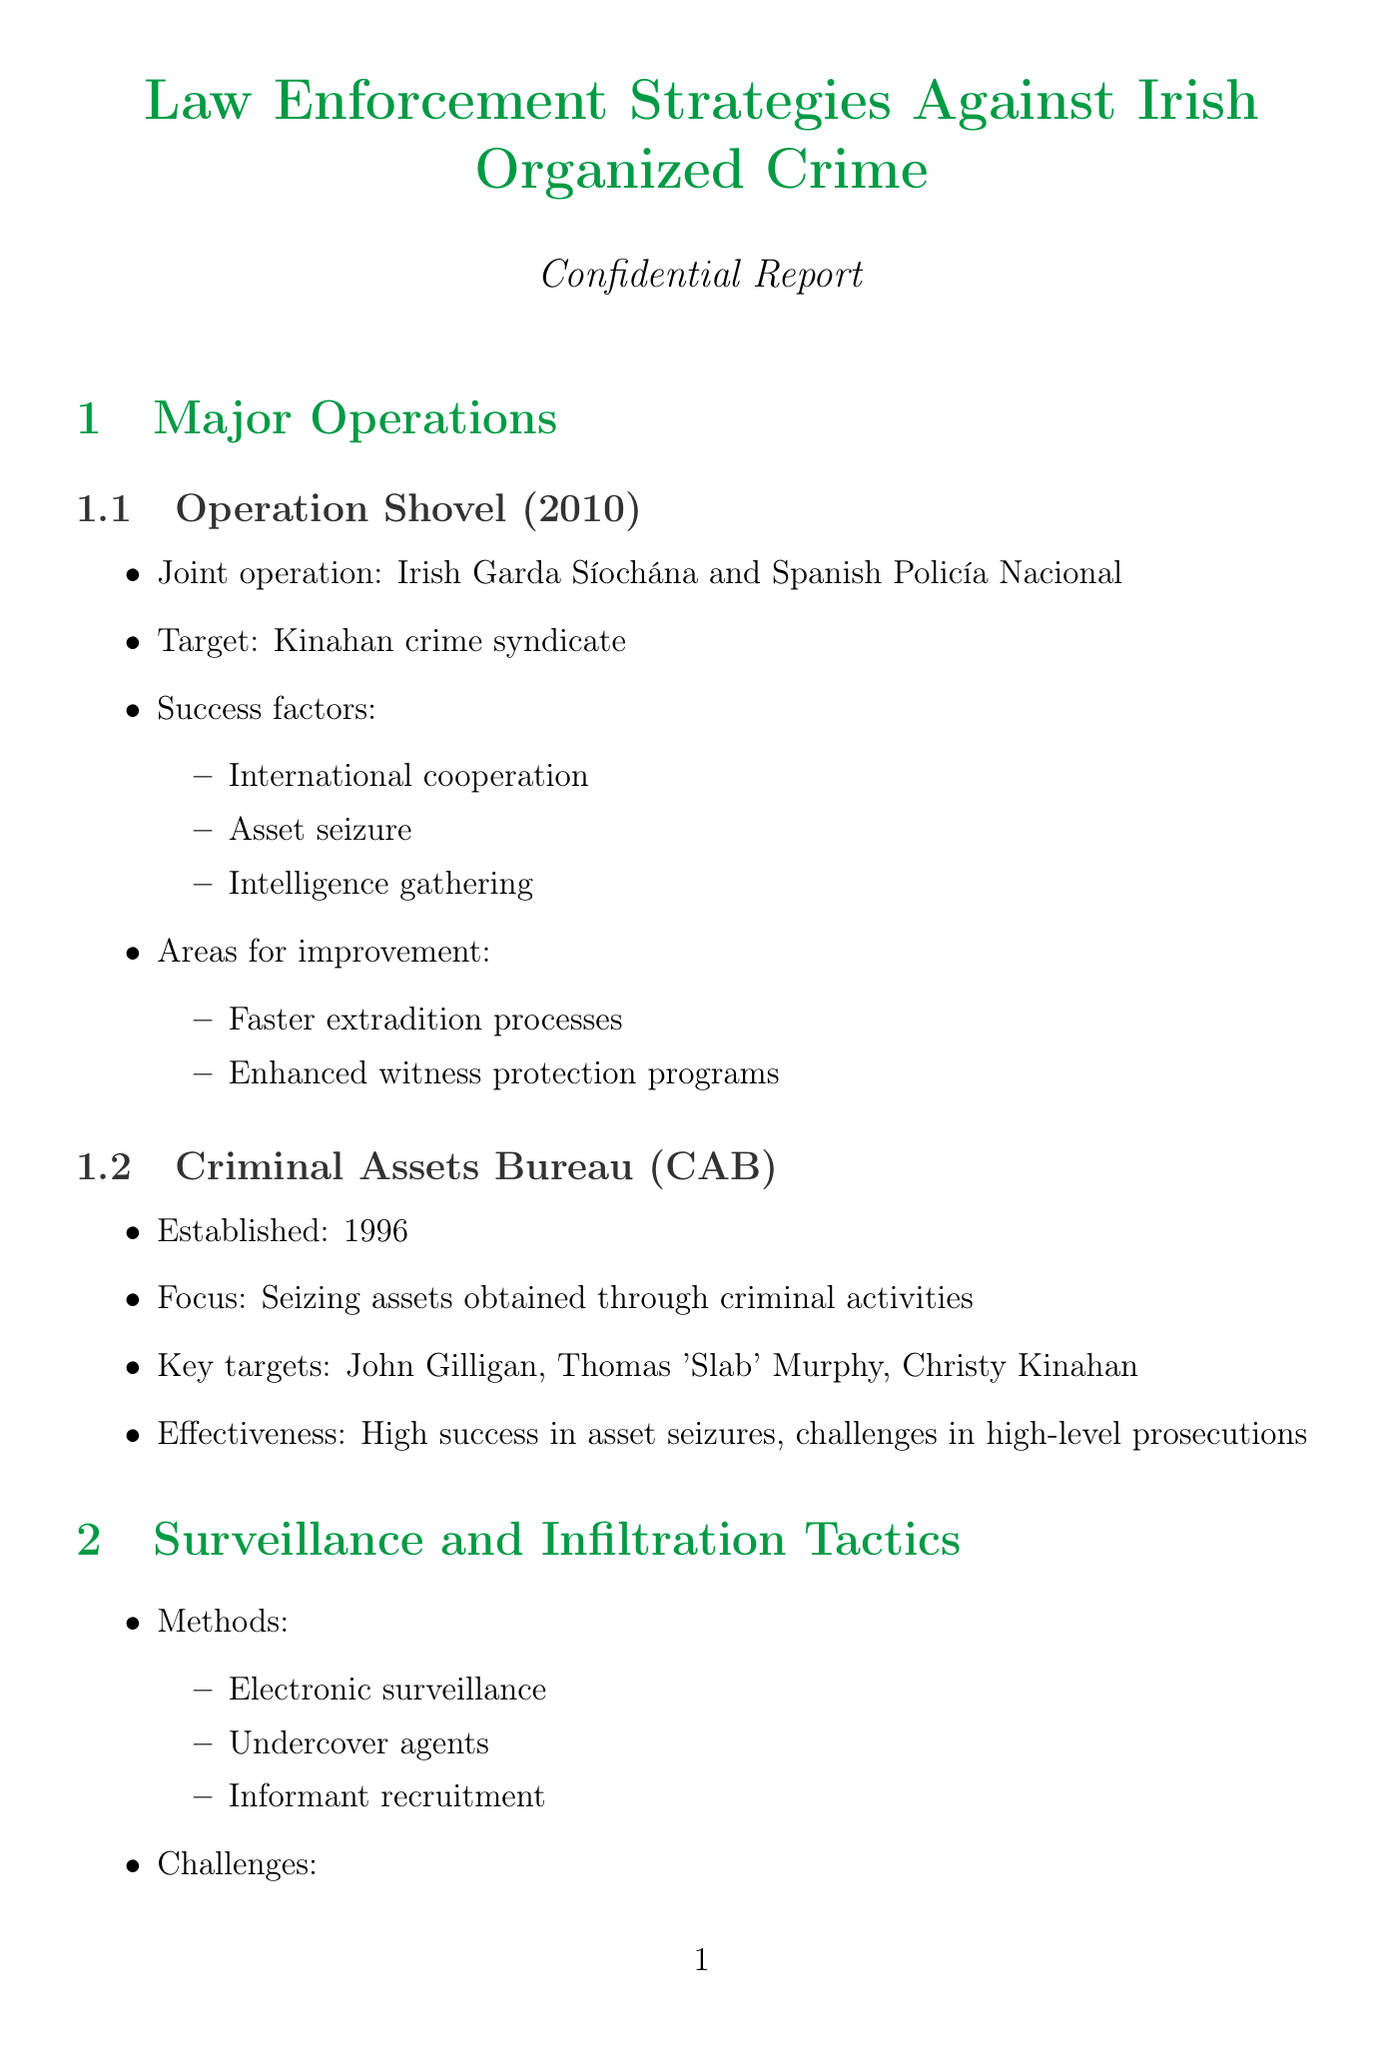what is the name of the joint operation targeting the Kinahan crime syndicate? The operation mentioned in the document is a joint effort between Irish Garda Síochána and Spanish Policía Nacional aimed at the Kinahan crime syndicate.
Answer: Operation Shovel when was the Criminal Assets Bureau established? The document states that the Criminal Assets Bureau, which focuses on seizing assets obtained through criminal activities, was established in 1996.
Answer: 1996 who is the leader of the Hutch Gang? The document identifies Gerry 'The Monk' Hutch as the leader of the Hutch Gang.
Answer: Gerry 'The Monk' Hutch what is one of the primary activities of the Kinahan Organized Crime Group? The document lists drug trafficking, money laundering, and arms dealing as primary activities of the Kinahan Organized Crime Group.
Answer: Drug trafficking what year was the Criminal Justice (Amendment) Act passed? The document indicates that the Criminal Justice (Amendment) Act was enacted in 2009.
Answer: 2009 what is the effectiveness rating of the Criminal Assets Bureau in terms of asset seizures? The text mentions a high success rate in asset seizures attributed to the Criminal Assets Bureau, albeit with challenges in high-level prosecutions.
Answer: High success rate what are the proposed actions for community engagement initiatives? The document outlines several proposed actions to engage the community, focusing on preventing youth recruitment into criminal organizations, including school outreach programs.
Answer: School outreach programs what is a challenge mentioned for the witness protection program enhancement? The document highlights limited resources as one of the challenges faced in enhancing the witness protection program.
Answer: Limited resources 